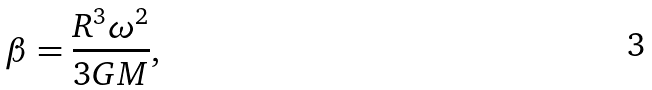<formula> <loc_0><loc_0><loc_500><loc_500>\beta = \frac { R ^ { 3 } \omega ^ { 2 } } { 3 G M } ,</formula> 